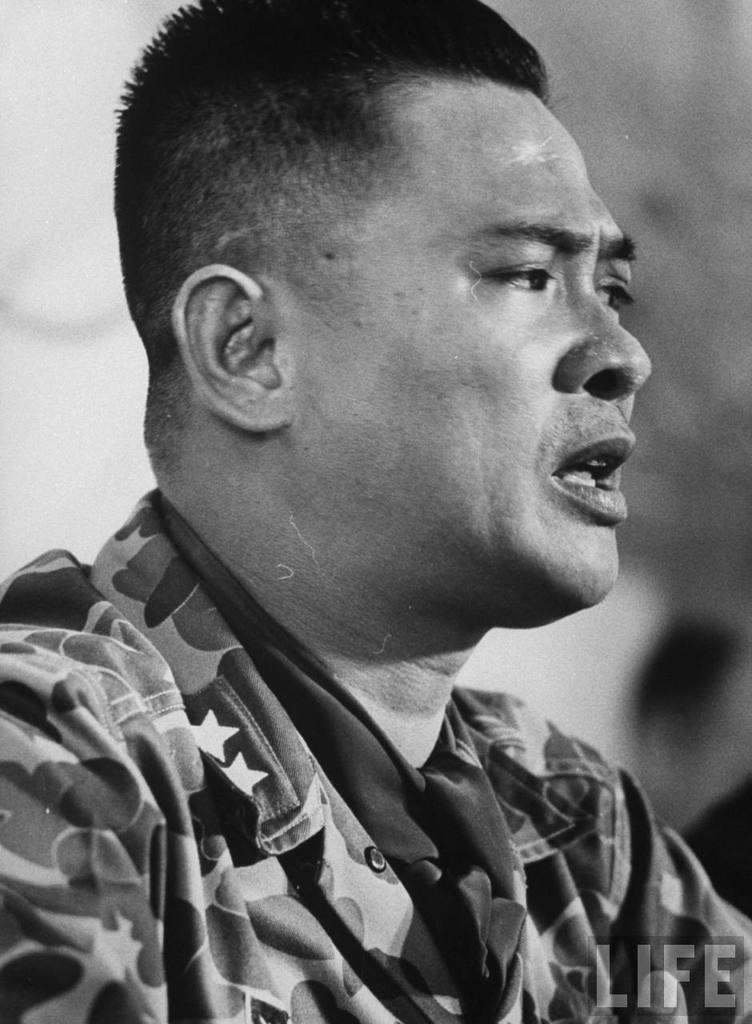Who or what is the main subject of the image? There is a person in the image. Can you describe the background of the image? The background of the image is blurry. Is there any text present in the image? Yes, there is text in the bottom right corner of the image. How many dogs are visible in the image? There are no dogs present in the image. What type of structure can be seen in the background of the image? The background of the image is blurry, so it is not possible to identify any structures. 